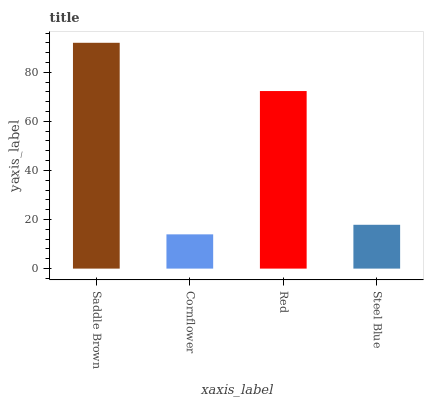Is Cornflower the minimum?
Answer yes or no. Yes. Is Saddle Brown the maximum?
Answer yes or no. Yes. Is Red the minimum?
Answer yes or no. No. Is Red the maximum?
Answer yes or no. No. Is Red greater than Cornflower?
Answer yes or no. Yes. Is Cornflower less than Red?
Answer yes or no. Yes. Is Cornflower greater than Red?
Answer yes or no. No. Is Red less than Cornflower?
Answer yes or no. No. Is Red the high median?
Answer yes or no. Yes. Is Steel Blue the low median?
Answer yes or no. Yes. Is Steel Blue the high median?
Answer yes or no. No. Is Saddle Brown the low median?
Answer yes or no. No. 